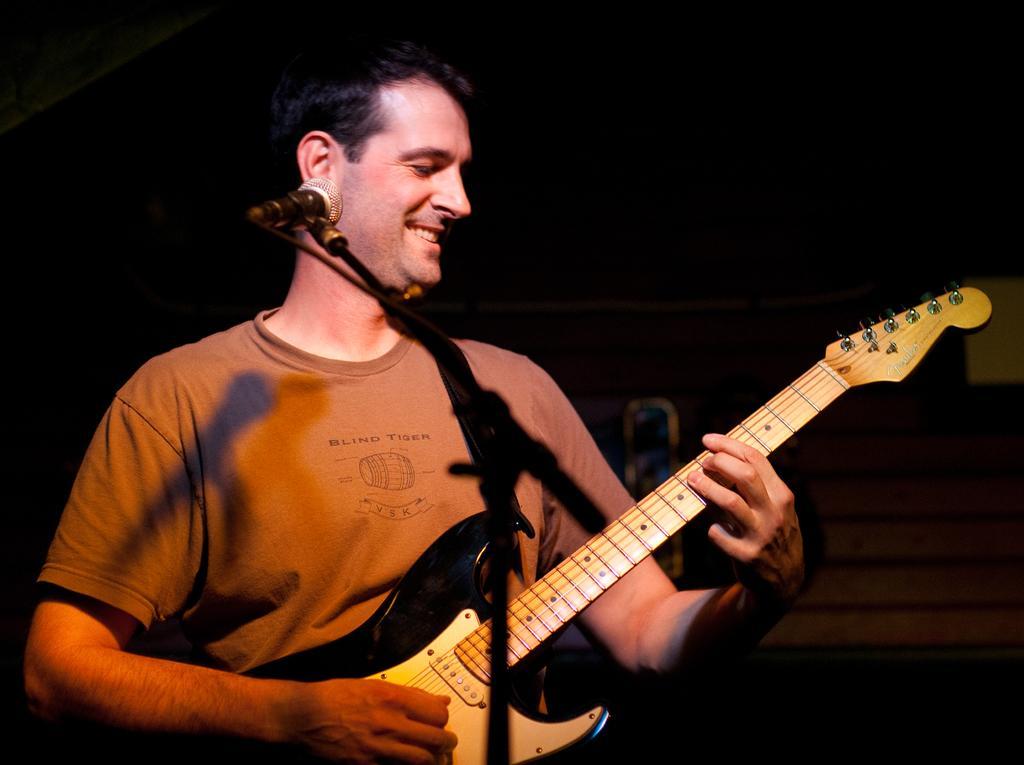Can you describe this image briefly? The man in the brown shirt is playing a guitar. There is a mic placed before him. 